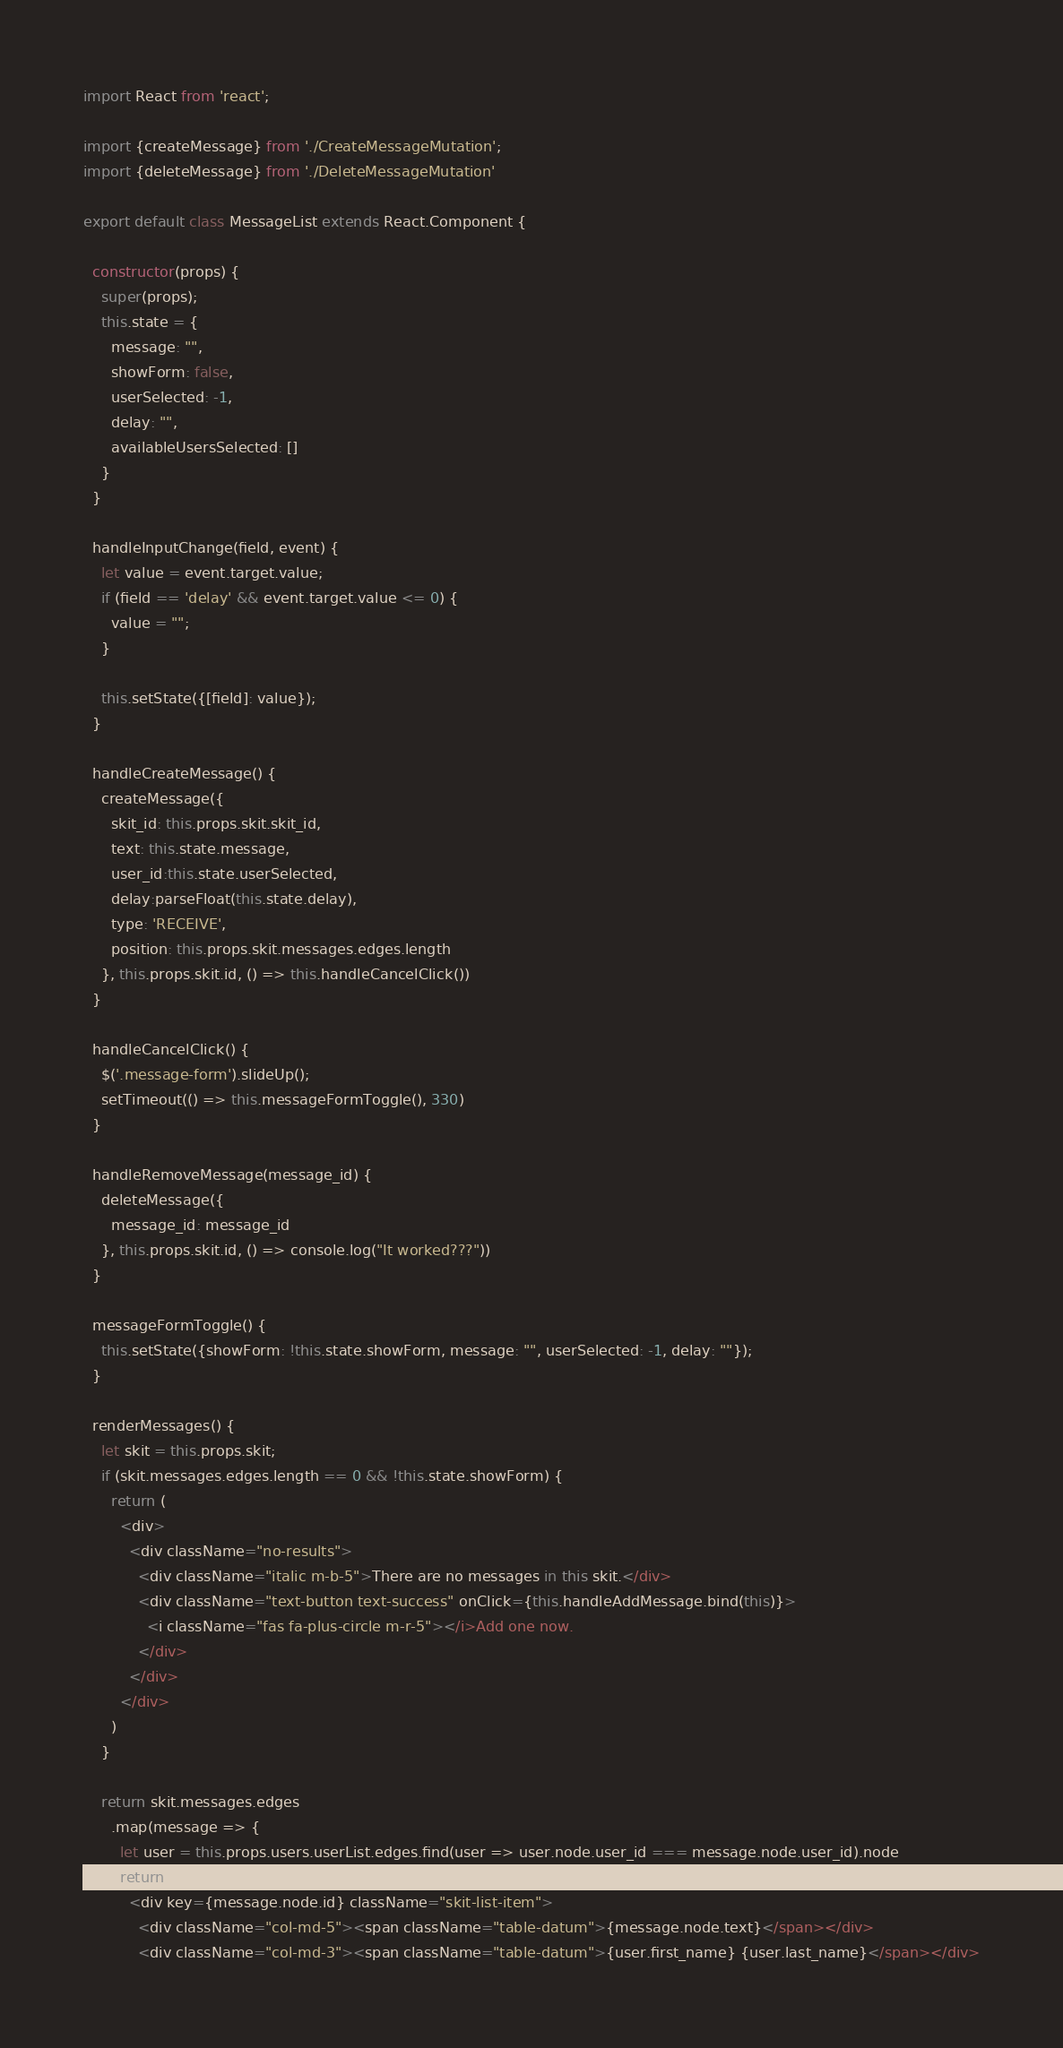<code> <loc_0><loc_0><loc_500><loc_500><_JavaScript_>import React from 'react';

import {createMessage} from './CreateMessageMutation';
import {deleteMessage} from './DeleteMessageMutation'

export default class MessageList extends React.Component {

  constructor(props) {
    super(props);
    this.state = {
      message: "",
      showForm: false,
      userSelected: -1,
      delay: "",
      availableUsersSelected: []
    }
  }

  handleInputChange(field, event) {
    let value = event.target.value;
    if (field == 'delay' && event.target.value <= 0) {
      value = "";
    }

    this.setState({[field]: value});
  }

  handleCreateMessage() {
    createMessage({
      skit_id: this.props.skit.skit_id,
      text: this.state.message,
      user_id:this.state.userSelected,
      delay:parseFloat(this.state.delay),
      type: 'RECEIVE',
      position: this.props.skit.messages.edges.length
    }, this.props.skit.id, () => this.handleCancelClick())
  }

  handleCancelClick() {
    $('.message-form').slideUp();
    setTimeout(() => this.messageFormToggle(), 330)
  }

  handleRemoveMessage(message_id) {
    deleteMessage({
      message_id: message_id
    }, this.props.skit.id, () => console.log("It worked???"))
  }

  messageFormToggle() {
    this.setState({showForm: !this.state.showForm, message: "", userSelected: -1, delay: ""});
  }

  renderMessages() {
    let skit = this.props.skit;
    if (skit.messages.edges.length == 0 && !this.state.showForm) {
      return (
        <div>
          <div className="no-results">
            <div className="italic m-b-5">There are no messages in this skit.</div>
            <div className="text-button text-success" onClick={this.handleAddMessage.bind(this)}>
              <i className="fas fa-plus-circle m-r-5"></i>Add one now.
            </div>
          </div>
        </div>
      )
    }

    return skit.messages.edges
      .map(message => {
        let user = this.props.users.userList.edges.find(user => user.node.user_id === message.node.user_id).node
        return (
          <div key={message.node.id} className="skit-list-item">
            <div className="col-md-5"><span className="table-datum">{message.node.text}</span></div>
            <div className="col-md-3"><span className="table-datum">{user.first_name} {user.last_name}</span></div></code> 